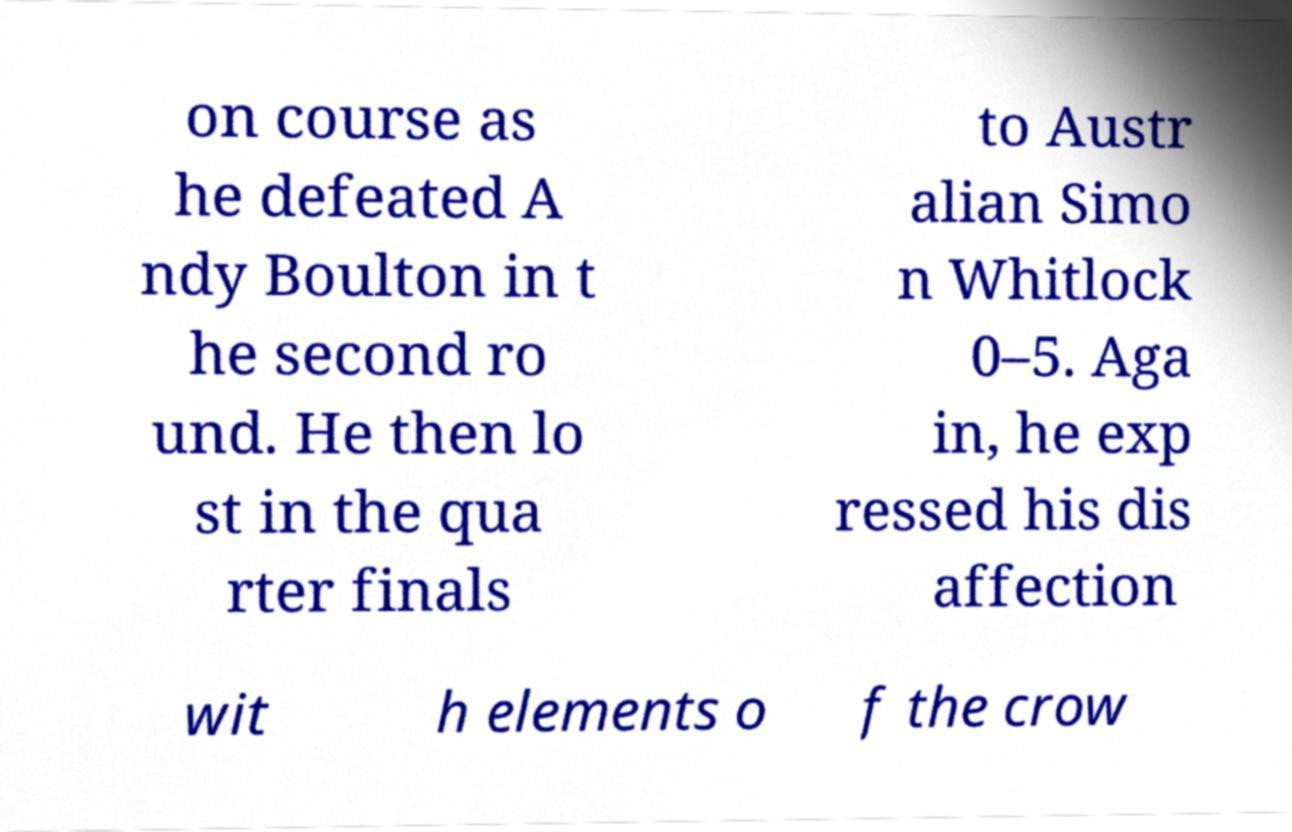Could you assist in decoding the text presented in this image and type it out clearly? on course as he defeated A ndy Boulton in t he second ro und. He then lo st in the qua rter finals to Austr alian Simo n Whitlock 0–5. Aga in, he exp ressed his dis affection wit h elements o f the crow 